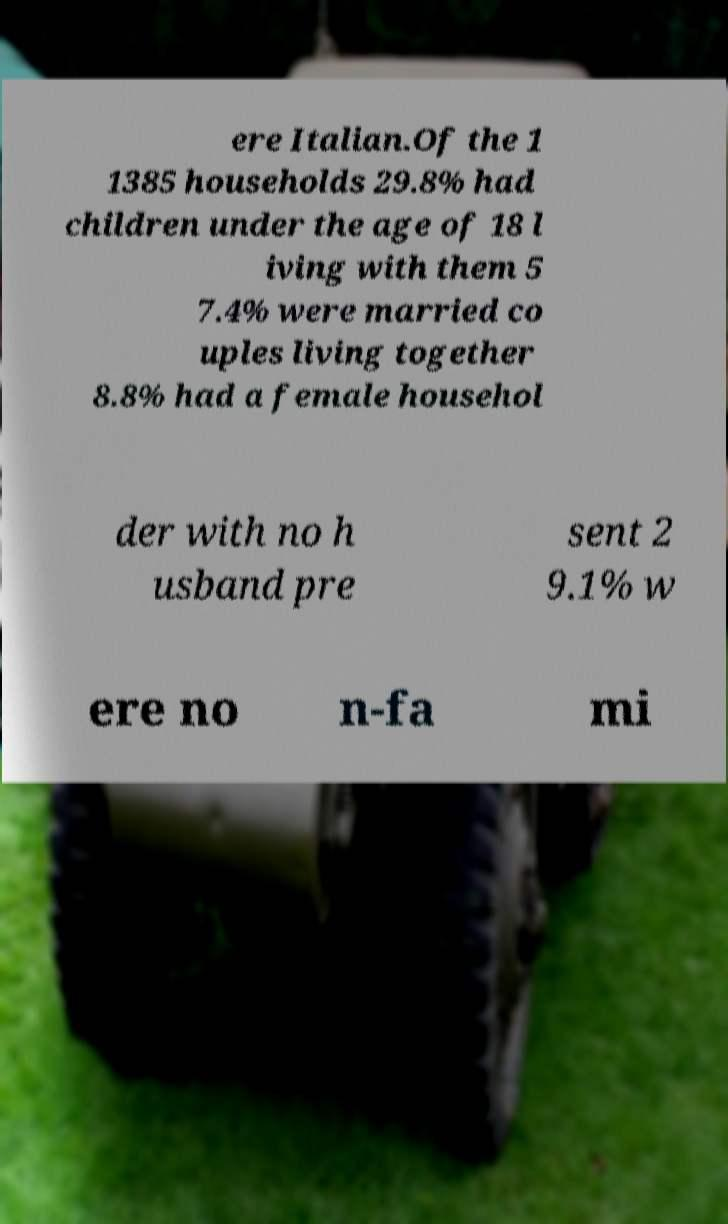Can you read and provide the text displayed in the image?This photo seems to have some interesting text. Can you extract and type it out for me? ere Italian.Of the 1 1385 households 29.8% had children under the age of 18 l iving with them 5 7.4% were married co uples living together 8.8% had a female househol der with no h usband pre sent 2 9.1% w ere no n-fa mi 